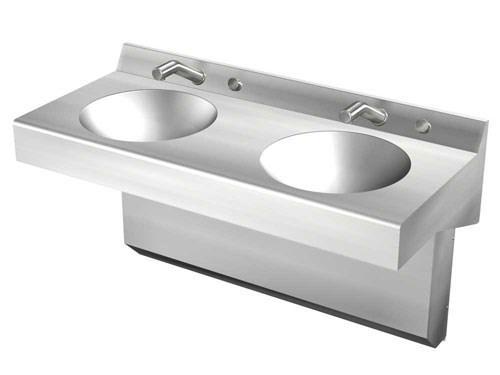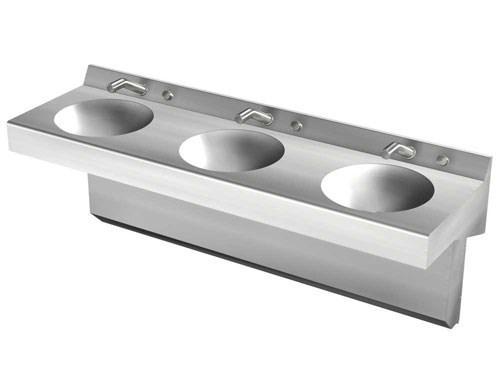The first image is the image on the left, the second image is the image on the right. Considering the images on both sides, is "Each sink featured has only one bowl, and one faucet." valid? Answer yes or no. No. The first image is the image on the left, the second image is the image on the right. For the images shown, is this caption "An image shows a long sink unit with at least three faucets." true? Answer yes or no. Yes. 